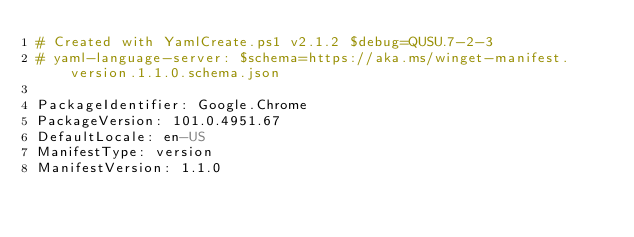Convert code to text. <code><loc_0><loc_0><loc_500><loc_500><_YAML_># Created with YamlCreate.ps1 v2.1.2 $debug=QUSU.7-2-3
# yaml-language-server: $schema=https://aka.ms/winget-manifest.version.1.1.0.schema.json

PackageIdentifier: Google.Chrome
PackageVersion: 101.0.4951.67
DefaultLocale: en-US
ManifestType: version
ManifestVersion: 1.1.0
</code> 